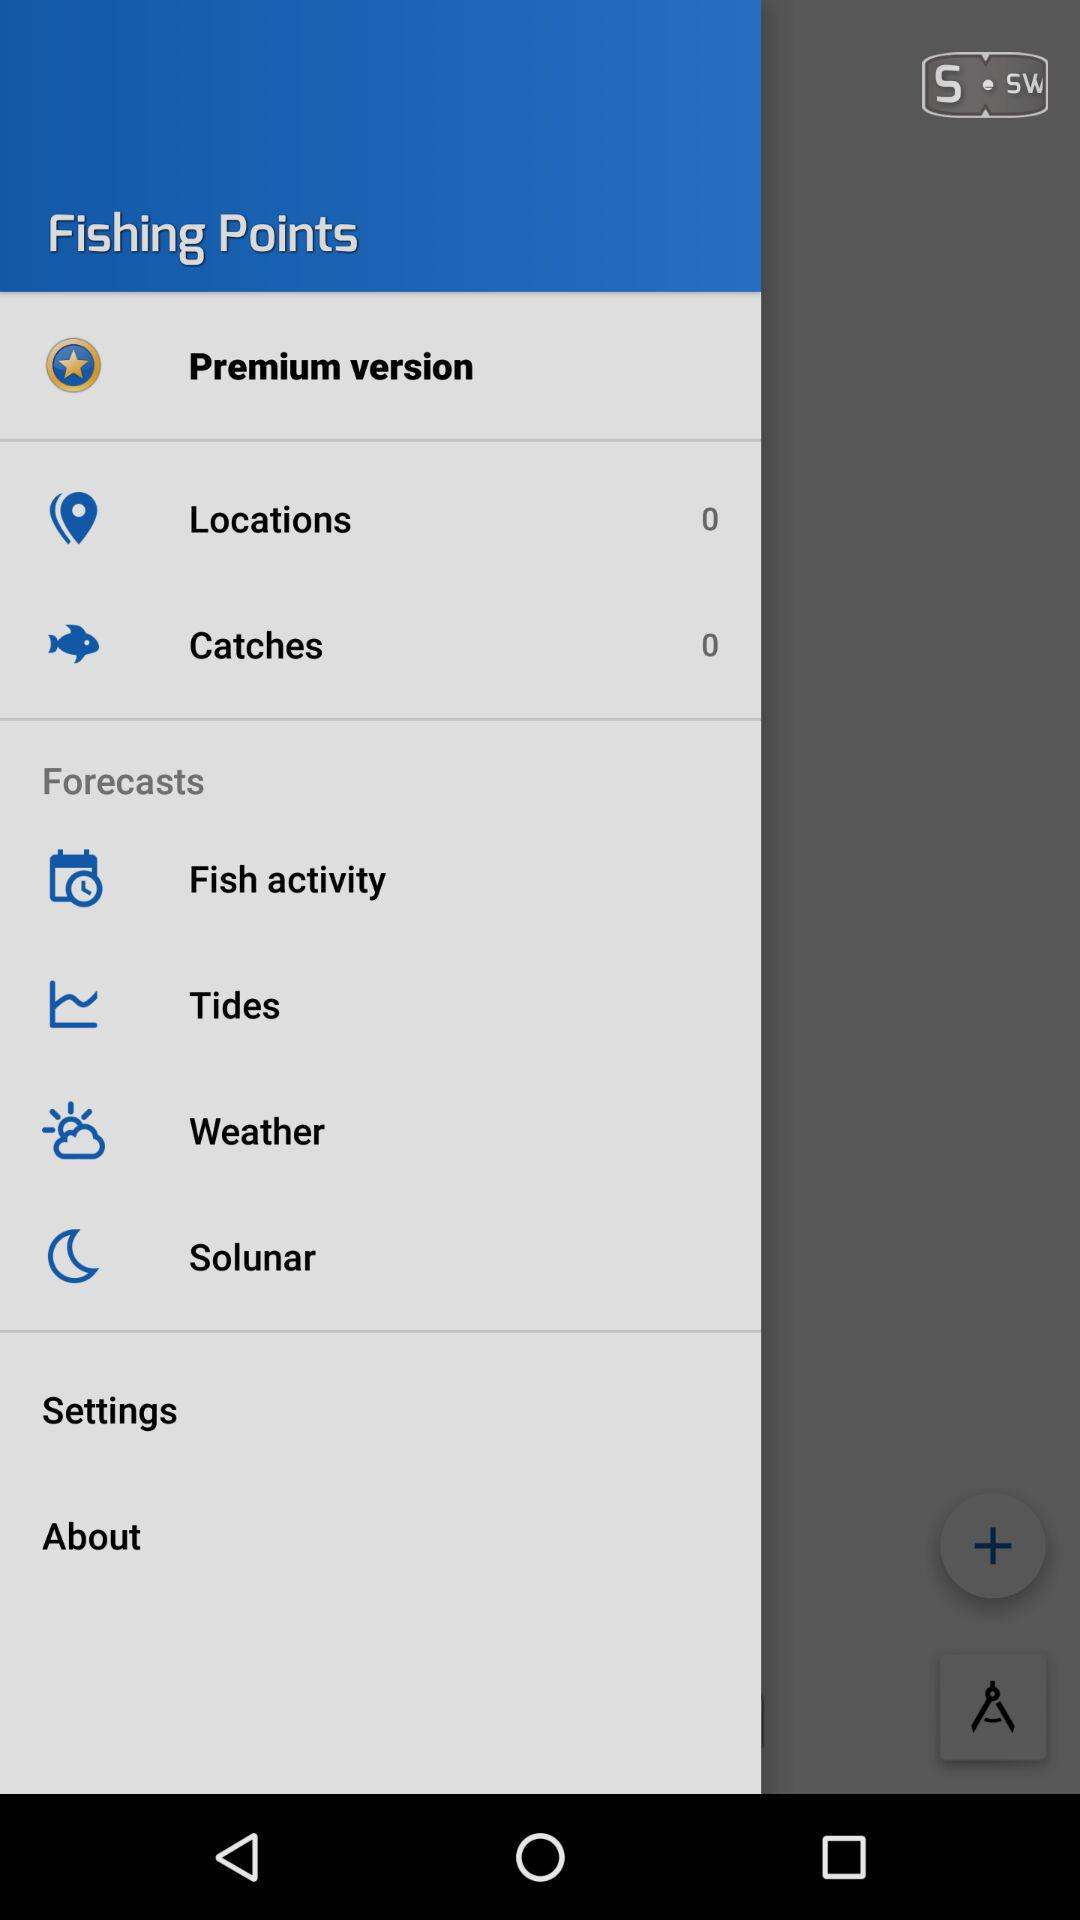When will the tide come in tomorrow?
When the provided information is insufficient, respond with <no answer>. <no answer> 